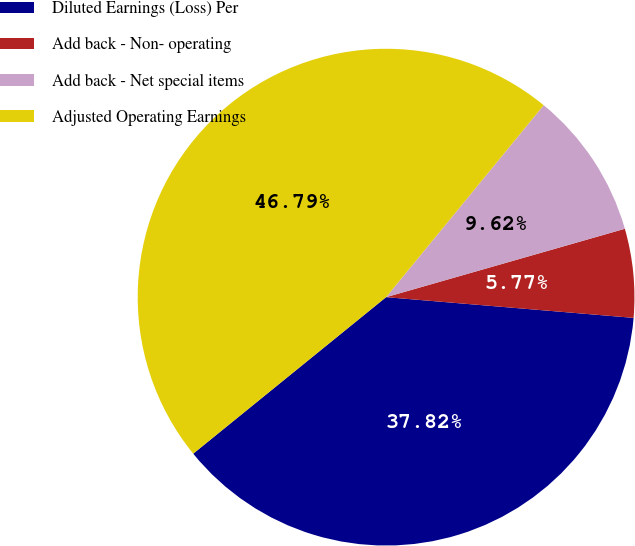Convert chart. <chart><loc_0><loc_0><loc_500><loc_500><pie_chart><fcel>Diluted Earnings (Loss) Per<fcel>Add back - Non- operating<fcel>Add back - Net special items<fcel>Adjusted Operating Earnings<nl><fcel>37.82%<fcel>5.77%<fcel>9.62%<fcel>46.79%<nl></chart> 